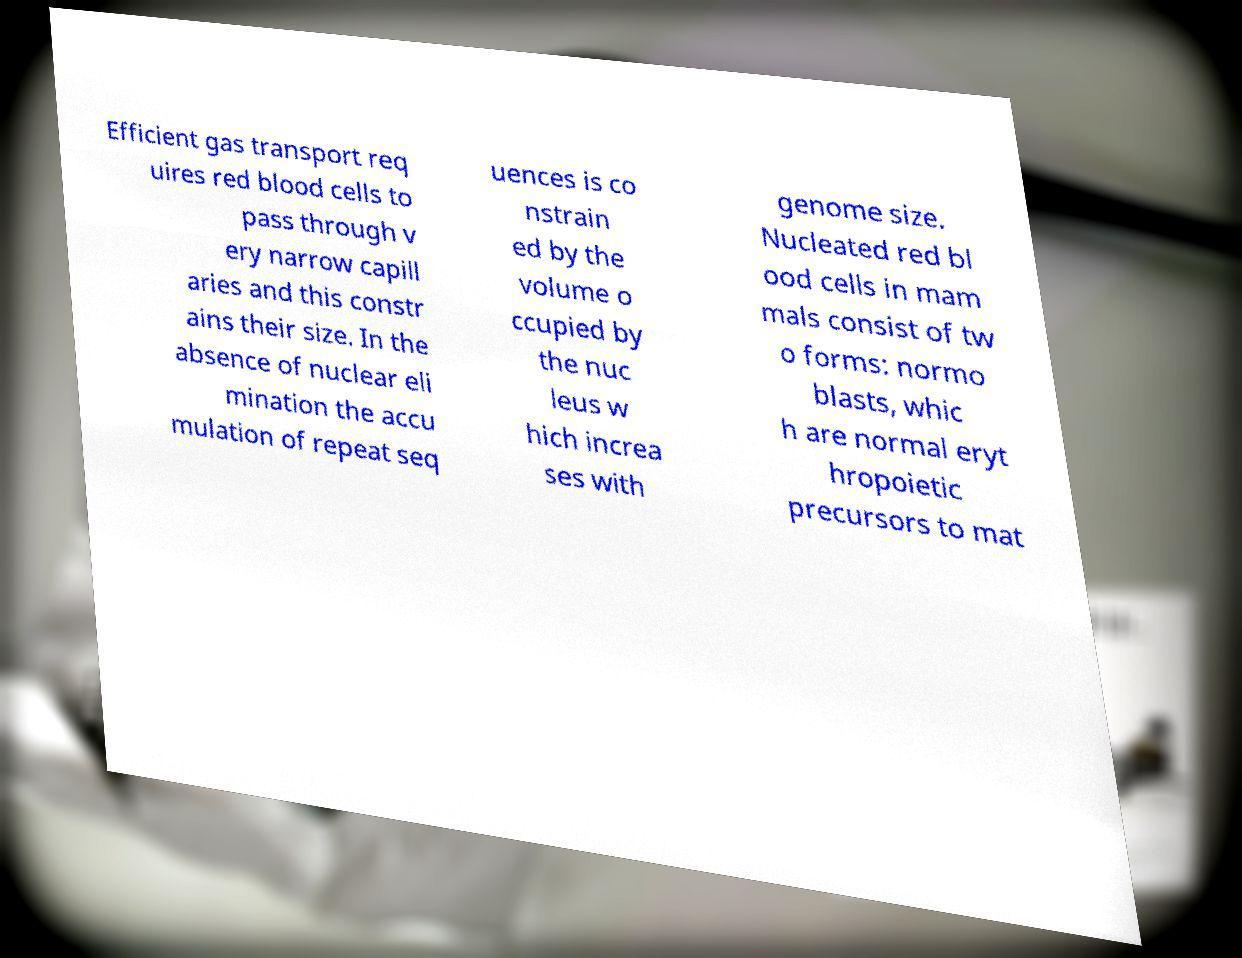For documentation purposes, I need the text within this image transcribed. Could you provide that? Efficient gas transport req uires red blood cells to pass through v ery narrow capill aries and this constr ains their size. In the absence of nuclear eli mination the accu mulation of repeat seq uences is co nstrain ed by the volume o ccupied by the nuc leus w hich increa ses with genome size. Nucleated red bl ood cells in mam mals consist of tw o forms: normo blasts, whic h are normal eryt hropoietic precursors to mat 